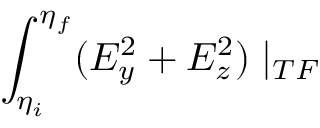<formula> <loc_0><loc_0><loc_500><loc_500>\int _ { \eta _ { i } } ^ { \eta _ { f } } ( E _ { y } ^ { 2 } + E _ { z } ^ { 2 } ) | _ { T F }</formula> 